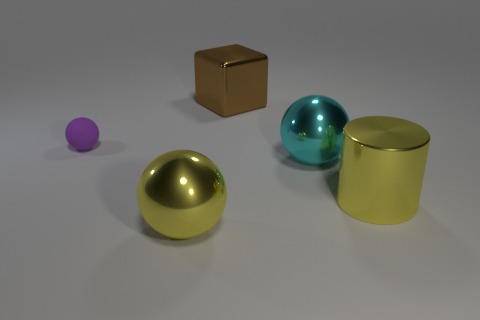What size is the thing that is the same color as the cylinder?
Provide a short and direct response. Large. Do the large cylinder and the large metal sphere that is in front of the cyan ball have the same color?
Provide a short and direct response. Yes. Are there fewer objects than small yellow spheres?
Offer a very short reply. No. How many other objects are there of the same color as the tiny thing?
Your answer should be very brief. 0. What number of big green things are there?
Ensure brevity in your answer.  0. Is the number of yellow metallic things behind the brown cube less than the number of tiny metal cylinders?
Provide a short and direct response. No. Is the material of the yellow object behind the large yellow sphere the same as the brown thing?
Give a very brief answer. Yes. The big yellow thing on the left side of the metal object that is on the right side of the big cyan sphere behind the big yellow metal ball is what shape?
Keep it short and to the point. Sphere. Is there a gray rubber block of the same size as the yellow metal ball?
Make the answer very short. No. What size is the cyan shiny object?
Your answer should be very brief. Large. 